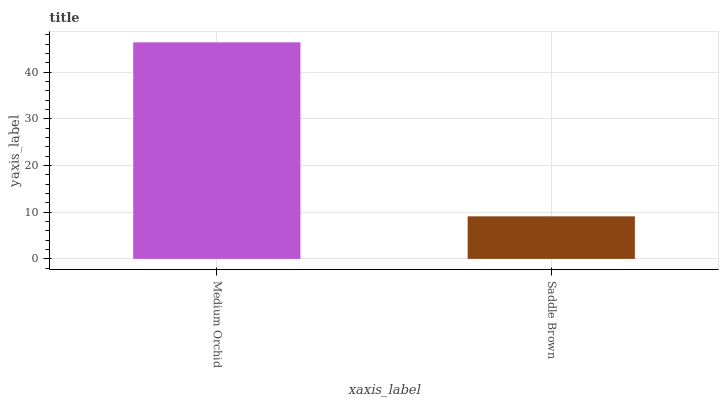Is Saddle Brown the minimum?
Answer yes or no. Yes. Is Medium Orchid the maximum?
Answer yes or no. Yes. Is Saddle Brown the maximum?
Answer yes or no. No. Is Medium Orchid greater than Saddle Brown?
Answer yes or no. Yes. Is Saddle Brown less than Medium Orchid?
Answer yes or no. Yes. Is Saddle Brown greater than Medium Orchid?
Answer yes or no. No. Is Medium Orchid less than Saddle Brown?
Answer yes or no. No. Is Medium Orchid the high median?
Answer yes or no. Yes. Is Saddle Brown the low median?
Answer yes or no. Yes. Is Saddle Brown the high median?
Answer yes or no. No. Is Medium Orchid the low median?
Answer yes or no. No. 